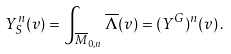Convert formula to latex. <formula><loc_0><loc_0><loc_500><loc_500>Y ^ { n } _ { S } ( v ) = \int _ { \overline { M } _ { 0 , n } } \overline { \Lambda } ( v ) = ( Y ^ { G } ) ^ { n } ( v ) \, .</formula> 